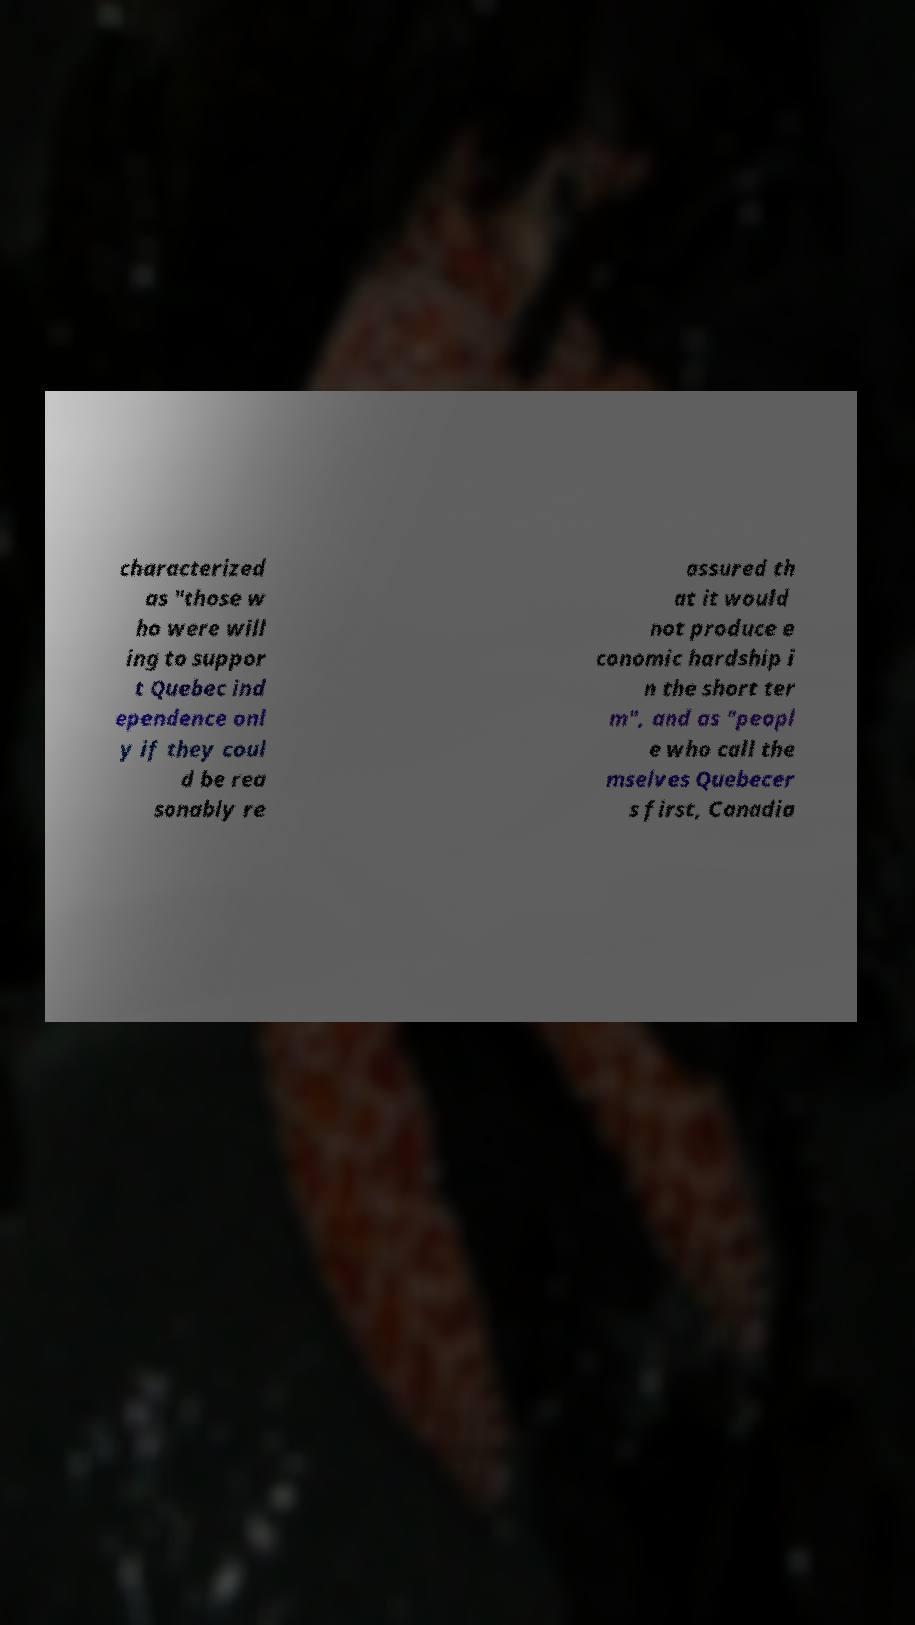Can you accurately transcribe the text from the provided image for me? characterized as "those w ho were will ing to suppor t Quebec ind ependence onl y if they coul d be rea sonably re assured th at it would not produce e conomic hardship i n the short ter m", and as "peopl e who call the mselves Quebecer s first, Canadia 